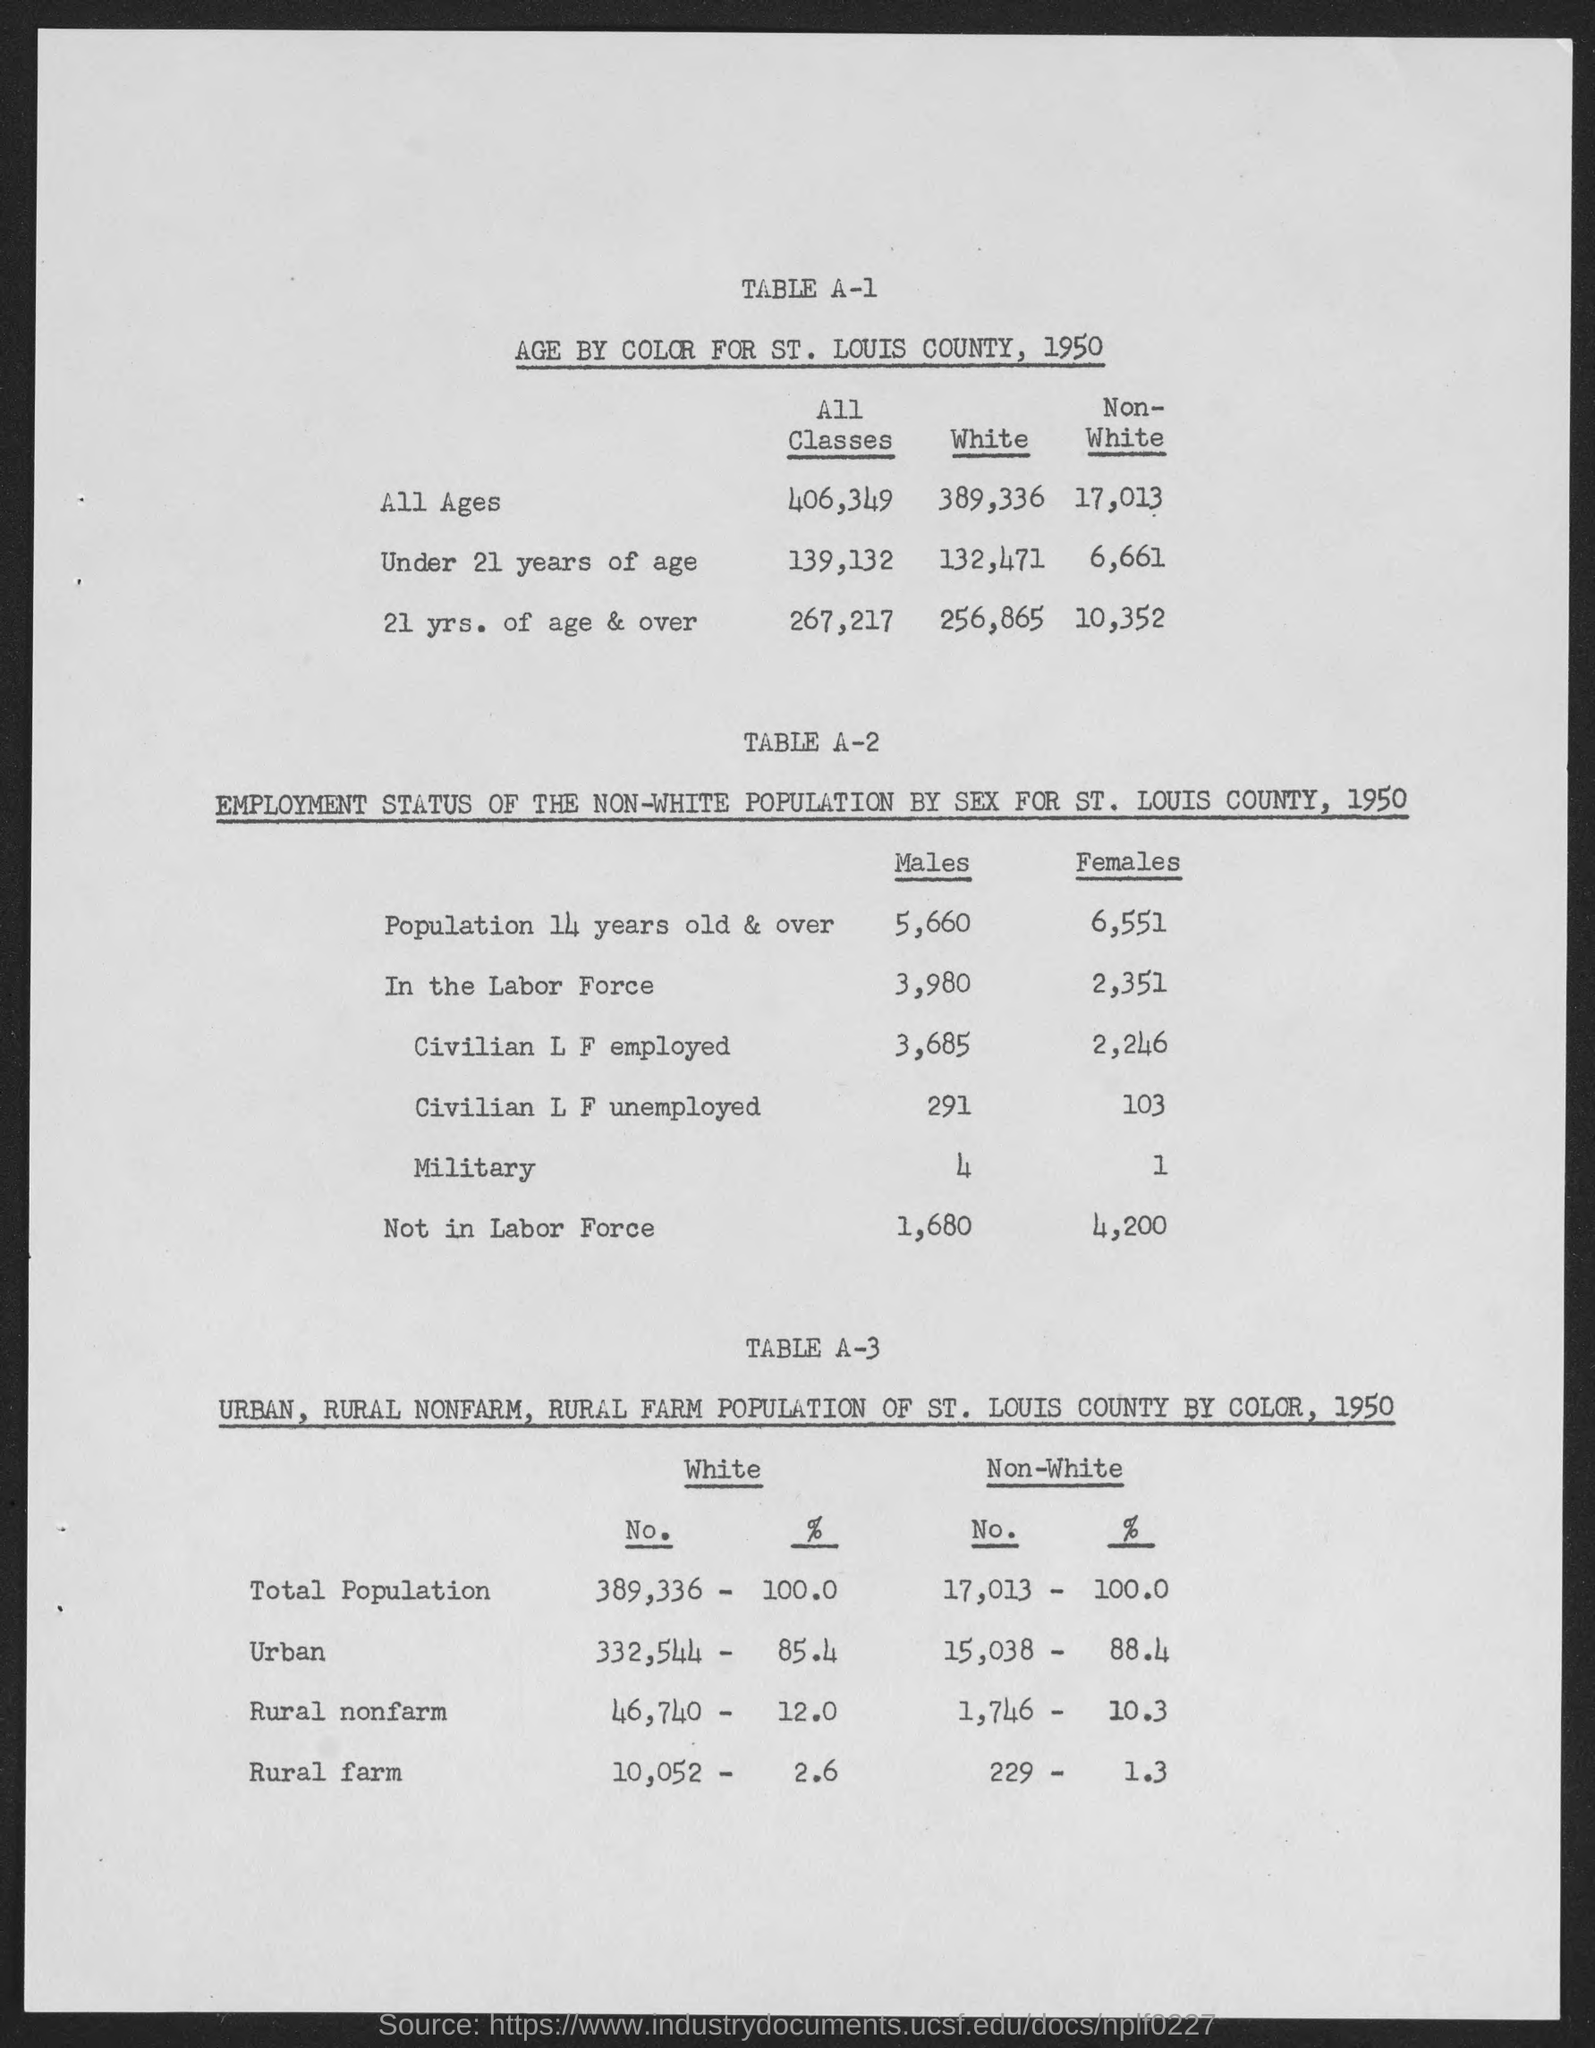Can you provide the percentage of the rural nonfarm population for white individuals in St. Louis in 1950? The rural nonfarm population for white individuals in St. Louis County in 1950 was 12.0%, amounting to 46,710 people. 